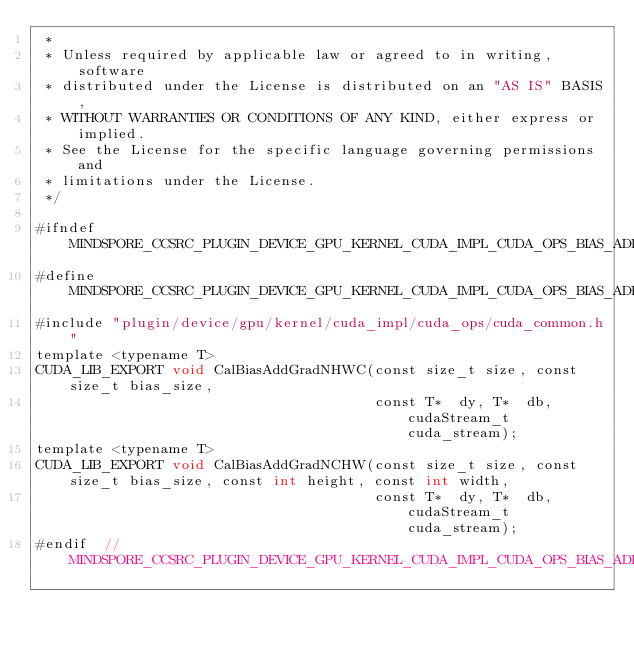Convert code to text. <code><loc_0><loc_0><loc_500><loc_500><_Cuda_> *
 * Unless required by applicable law or agreed to in writing, software
 * distributed under the License is distributed on an "AS IS" BASIS,
 * WITHOUT WARRANTIES OR CONDITIONS OF ANY KIND, either express or implied.
 * See the License for the specific language governing permissions and
 * limitations under the License.
 */

#ifndef MINDSPORE_CCSRC_PLUGIN_DEVICE_GPU_KERNEL_CUDA_IMPL_CUDA_OPS_BIAS_ADD_GRAD_IMPL_CUH_
#define MINDSPORE_CCSRC_PLUGIN_DEVICE_GPU_KERNEL_CUDA_IMPL_CUDA_OPS_BIAS_ADD_GRAD_IMPL_CUH_
#include "plugin/device/gpu/kernel/cuda_impl/cuda_ops/cuda_common.h"
template <typename T>
CUDA_LIB_EXPORT void CalBiasAddGradNHWC(const size_t size, const size_t bias_size,
                                        const T*  dy, T*  db,  cudaStream_t cuda_stream);
template <typename T>
CUDA_LIB_EXPORT void CalBiasAddGradNCHW(const size_t size, const size_t bias_size, const int height, const int width,
                                        const T*  dy, T*  db,  cudaStream_t cuda_stream);
#endif  // MINDSPORE_CCSRC_PLUGIN_DEVICE_GPU_KERNEL_CUDA_IMPL_CUDA_OPS_BIAS_ADD_GRAD_IMPL_CUH_
</code> 